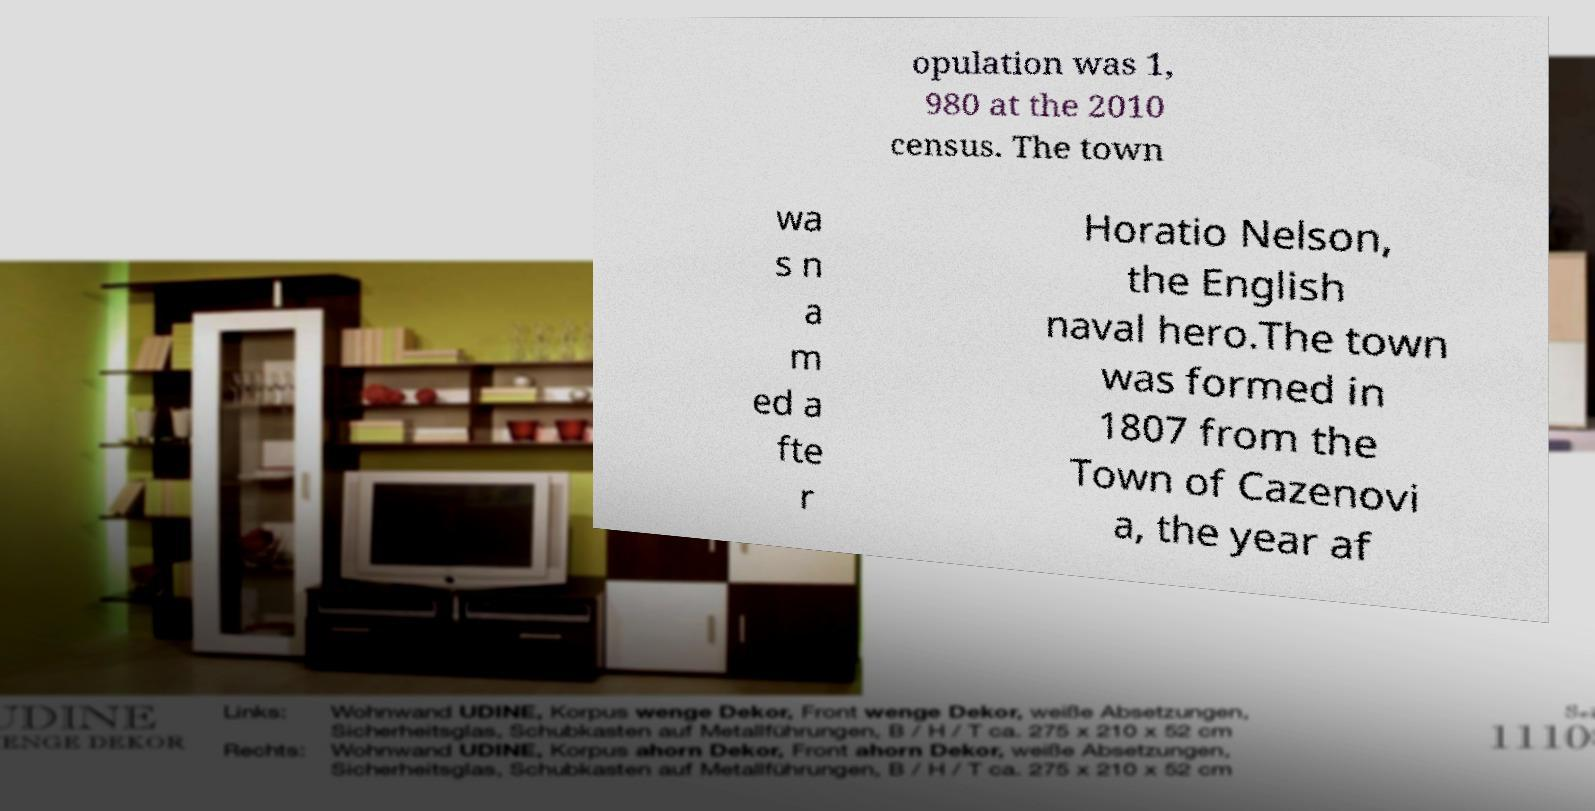Please read and relay the text visible in this image. What does it say? opulation was 1, 980 at the 2010 census. The town wa s n a m ed a fte r Horatio Nelson, the English naval hero.The town was formed in 1807 from the Town of Cazenovi a, the year af 